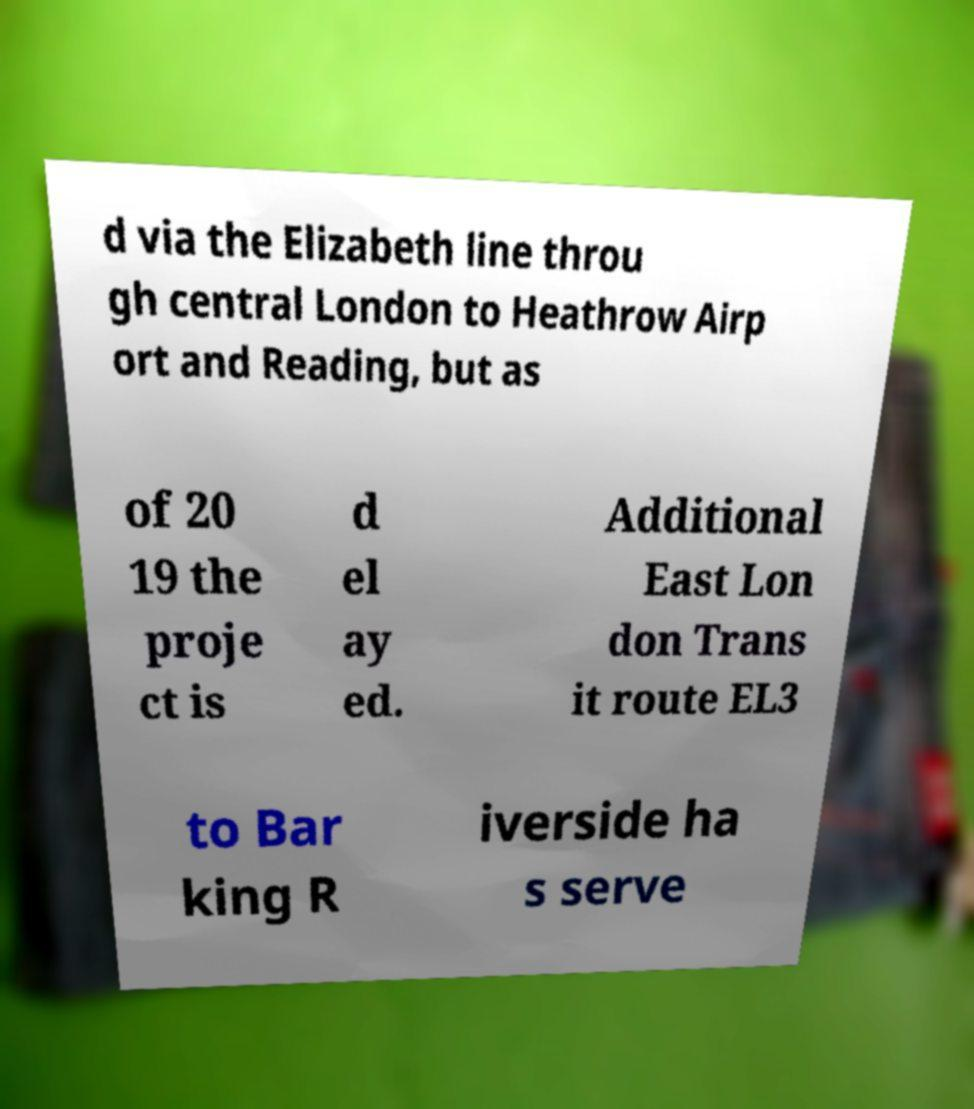What messages or text are displayed in this image? I need them in a readable, typed format. d via the Elizabeth line throu gh central London to Heathrow Airp ort and Reading, but as of 20 19 the proje ct is d el ay ed. Additional East Lon don Trans it route EL3 to Bar king R iverside ha s serve 